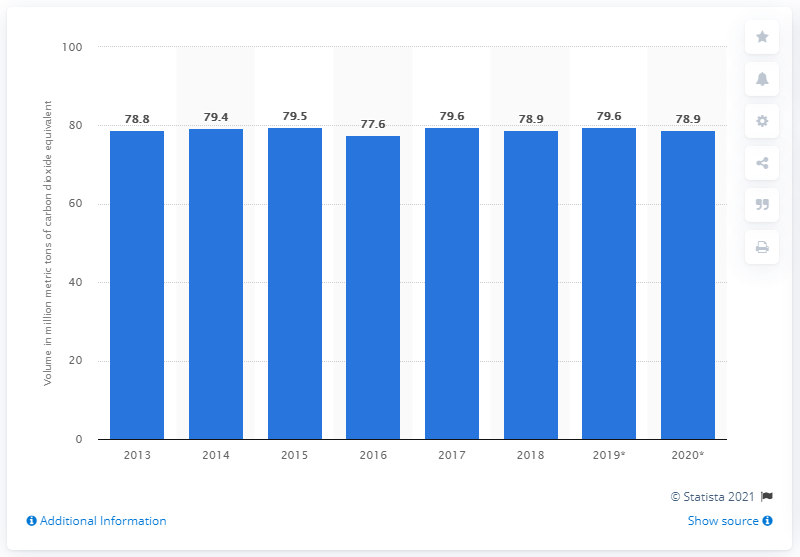Give some essential details in this illustration. In 2018, the gross volume of greenhouse gas emissions in New Zealand was 78.9... 